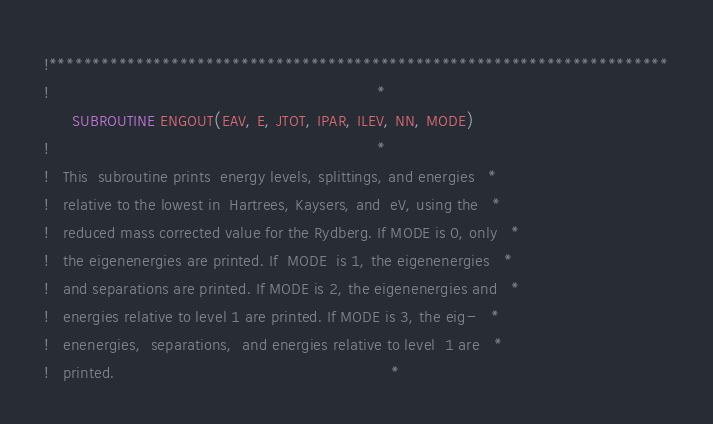Convert code to text. <code><loc_0><loc_0><loc_500><loc_500><_FORTRAN_>!***********************************************************************
!                                                                      *
      SUBROUTINE ENGOUT(EAV, E, JTOT, IPAR, ILEV, NN, MODE)
!                                                                      *
!   This  subroutine prints  energy levels, splittings, and energies   *
!   relative to the lowest in  Hartrees, Kaysers, and  eV, using the   *
!   reduced mass corrected value for the Rydberg. If MODE is 0, only   *
!   the eigenenergies are printed. If  MODE  is 1, the eigenenergies   *
!   and separations are printed. If MODE is 2, the eigenenergies and   *
!   energies relative to level 1 are printed. If MODE is 3, the eig-   *
!   enenergies,  separations,  and energies relative to level  1 are   *
!   printed.                                                           *</code> 